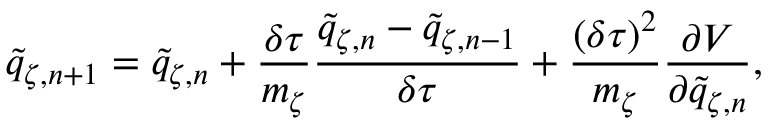<formula> <loc_0><loc_0><loc_500><loc_500>\tilde { q } _ { \zeta , n + 1 } = \tilde { q } _ { \zeta , n } + \frac { \delta \tau } { m _ { \zeta } } \frac { \tilde { q } _ { \zeta , n } - \tilde { q } _ { \zeta , n - 1 } } { \delta \tau } + \frac { ( \delta \tau ) ^ { 2 } } { m _ { \zeta } } \frac { \partial V } { \partial \tilde { q } _ { \zeta , n } } ,</formula> 